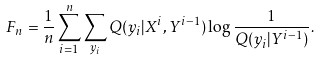<formula> <loc_0><loc_0><loc_500><loc_500>F _ { n } = \frac { 1 } { n } \sum _ { i = 1 } ^ { n } \sum _ { y _ { i } } Q ( y _ { i } | X ^ { i } , Y ^ { i - 1 } ) \log \frac { 1 } { Q ( y _ { i } | Y ^ { i - 1 } ) } .</formula> 